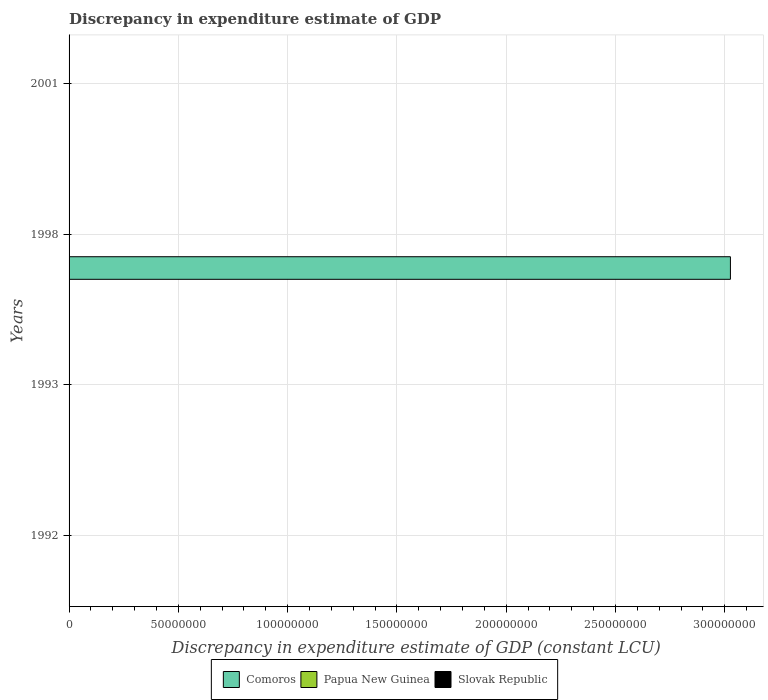How many different coloured bars are there?
Make the answer very short. 2. Are the number of bars per tick equal to the number of legend labels?
Your response must be concise. No. Are the number of bars on each tick of the Y-axis equal?
Your answer should be compact. No. Across all years, what is the maximum discrepancy in expenditure estimate of GDP in Comoros?
Ensure brevity in your answer.  3.03e+08. Across all years, what is the minimum discrepancy in expenditure estimate of GDP in Comoros?
Provide a succinct answer. 0. What is the total discrepancy in expenditure estimate of GDP in Slovak Republic in the graph?
Give a very brief answer. 0. What is the average discrepancy in expenditure estimate of GDP in Comoros per year?
Ensure brevity in your answer.  7.56e+07. In the year 1998, what is the difference between the discrepancy in expenditure estimate of GDP in Papua New Guinea and discrepancy in expenditure estimate of GDP in Comoros?
Give a very brief answer. -3.03e+08. Is the difference between the discrepancy in expenditure estimate of GDP in Papua New Guinea in 1998 and 2001 greater than the difference between the discrepancy in expenditure estimate of GDP in Comoros in 1998 and 2001?
Keep it short and to the point. No. What is the difference between the highest and the lowest discrepancy in expenditure estimate of GDP in Papua New Guinea?
Make the answer very short. 3.20e+04. In how many years, is the discrepancy in expenditure estimate of GDP in Slovak Republic greater than the average discrepancy in expenditure estimate of GDP in Slovak Republic taken over all years?
Offer a very short reply. 0. What is the difference between two consecutive major ticks on the X-axis?
Give a very brief answer. 5.00e+07. Does the graph contain grids?
Provide a succinct answer. Yes. Where does the legend appear in the graph?
Your answer should be compact. Bottom center. How many legend labels are there?
Offer a very short reply. 3. What is the title of the graph?
Your answer should be compact. Discrepancy in expenditure estimate of GDP. What is the label or title of the X-axis?
Keep it short and to the point. Discrepancy in expenditure estimate of GDP (constant LCU). What is the Discrepancy in expenditure estimate of GDP (constant LCU) in Comoros in 1992?
Provide a short and direct response. 0. What is the Discrepancy in expenditure estimate of GDP (constant LCU) of Slovak Republic in 1992?
Your answer should be very brief. 0. What is the Discrepancy in expenditure estimate of GDP (constant LCU) of Papua New Guinea in 1993?
Offer a terse response. 0. What is the Discrepancy in expenditure estimate of GDP (constant LCU) in Comoros in 1998?
Offer a terse response. 3.03e+08. What is the Discrepancy in expenditure estimate of GDP (constant LCU) in Papua New Guinea in 1998?
Make the answer very short. 1800. What is the Discrepancy in expenditure estimate of GDP (constant LCU) of Comoros in 2001?
Offer a very short reply. 100. What is the Discrepancy in expenditure estimate of GDP (constant LCU) in Papua New Guinea in 2001?
Make the answer very short. 3.20e+04. Across all years, what is the maximum Discrepancy in expenditure estimate of GDP (constant LCU) of Comoros?
Ensure brevity in your answer.  3.03e+08. Across all years, what is the maximum Discrepancy in expenditure estimate of GDP (constant LCU) in Papua New Guinea?
Keep it short and to the point. 3.20e+04. Across all years, what is the minimum Discrepancy in expenditure estimate of GDP (constant LCU) in Papua New Guinea?
Provide a short and direct response. 0. What is the total Discrepancy in expenditure estimate of GDP (constant LCU) in Comoros in the graph?
Provide a short and direct response. 3.03e+08. What is the total Discrepancy in expenditure estimate of GDP (constant LCU) of Papua New Guinea in the graph?
Ensure brevity in your answer.  3.38e+04. What is the difference between the Discrepancy in expenditure estimate of GDP (constant LCU) of Comoros in 1998 and that in 2001?
Provide a short and direct response. 3.03e+08. What is the difference between the Discrepancy in expenditure estimate of GDP (constant LCU) of Papua New Guinea in 1998 and that in 2001?
Your response must be concise. -3.02e+04. What is the difference between the Discrepancy in expenditure estimate of GDP (constant LCU) in Comoros in 1998 and the Discrepancy in expenditure estimate of GDP (constant LCU) in Papua New Guinea in 2001?
Your answer should be compact. 3.03e+08. What is the average Discrepancy in expenditure estimate of GDP (constant LCU) in Comoros per year?
Your answer should be very brief. 7.56e+07. What is the average Discrepancy in expenditure estimate of GDP (constant LCU) of Papua New Guinea per year?
Your answer should be very brief. 8450. In the year 1998, what is the difference between the Discrepancy in expenditure estimate of GDP (constant LCU) of Comoros and Discrepancy in expenditure estimate of GDP (constant LCU) of Papua New Guinea?
Keep it short and to the point. 3.03e+08. In the year 2001, what is the difference between the Discrepancy in expenditure estimate of GDP (constant LCU) of Comoros and Discrepancy in expenditure estimate of GDP (constant LCU) of Papua New Guinea?
Your answer should be very brief. -3.19e+04. What is the ratio of the Discrepancy in expenditure estimate of GDP (constant LCU) of Comoros in 1998 to that in 2001?
Offer a terse response. 3.03e+06. What is the ratio of the Discrepancy in expenditure estimate of GDP (constant LCU) of Papua New Guinea in 1998 to that in 2001?
Provide a succinct answer. 0.06. What is the difference between the highest and the lowest Discrepancy in expenditure estimate of GDP (constant LCU) in Comoros?
Keep it short and to the point. 3.03e+08. What is the difference between the highest and the lowest Discrepancy in expenditure estimate of GDP (constant LCU) in Papua New Guinea?
Keep it short and to the point. 3.20e+04. 